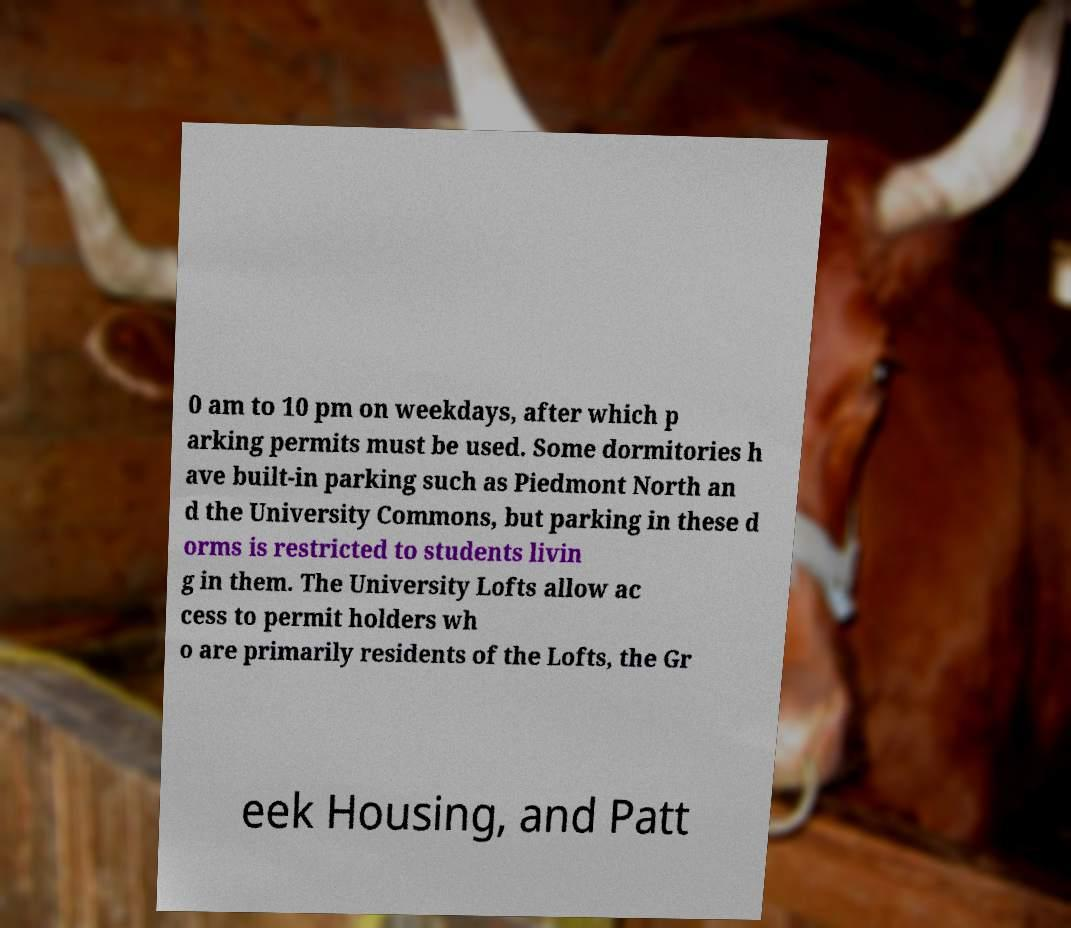Can you accurately transcribe the text from the provided image for me? 0 am to 10 pm on weekdays, after which p arking permits must be used. Some dormitories h ave built-in parking such as Piedmont North an d the University Commons, but parking in these d orms is restricted to students livin g in them. The University Lofts allow ac cess to permit holders wh o are primarily residents of the Lofts, the Gr eek Housing, and Patt 